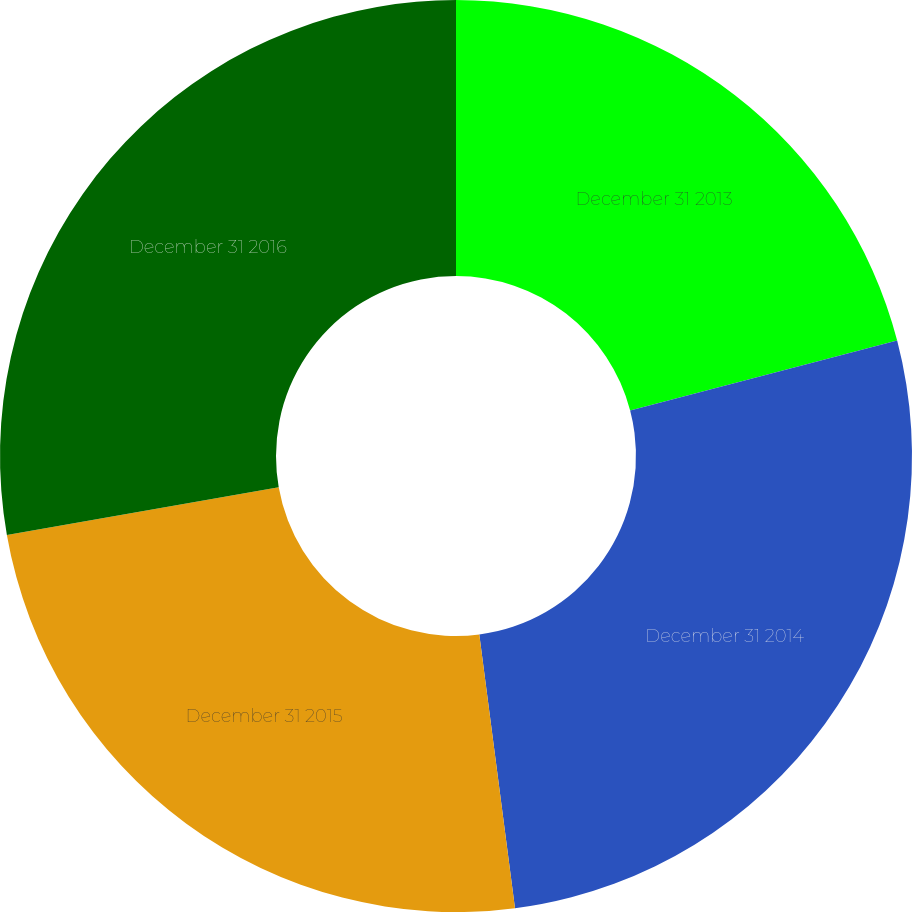<chart> <loc_0><loc_0><loc_500><loc_500><pie_chart><fcel>December 31 2013<fcel>December 31 2014<fcel>December 31 2015<fcel>December 31 2016<nl><fcel>20.93%<fcel>27.01%<fcel>24.3%<fcel>27.77%<nl></chart> 